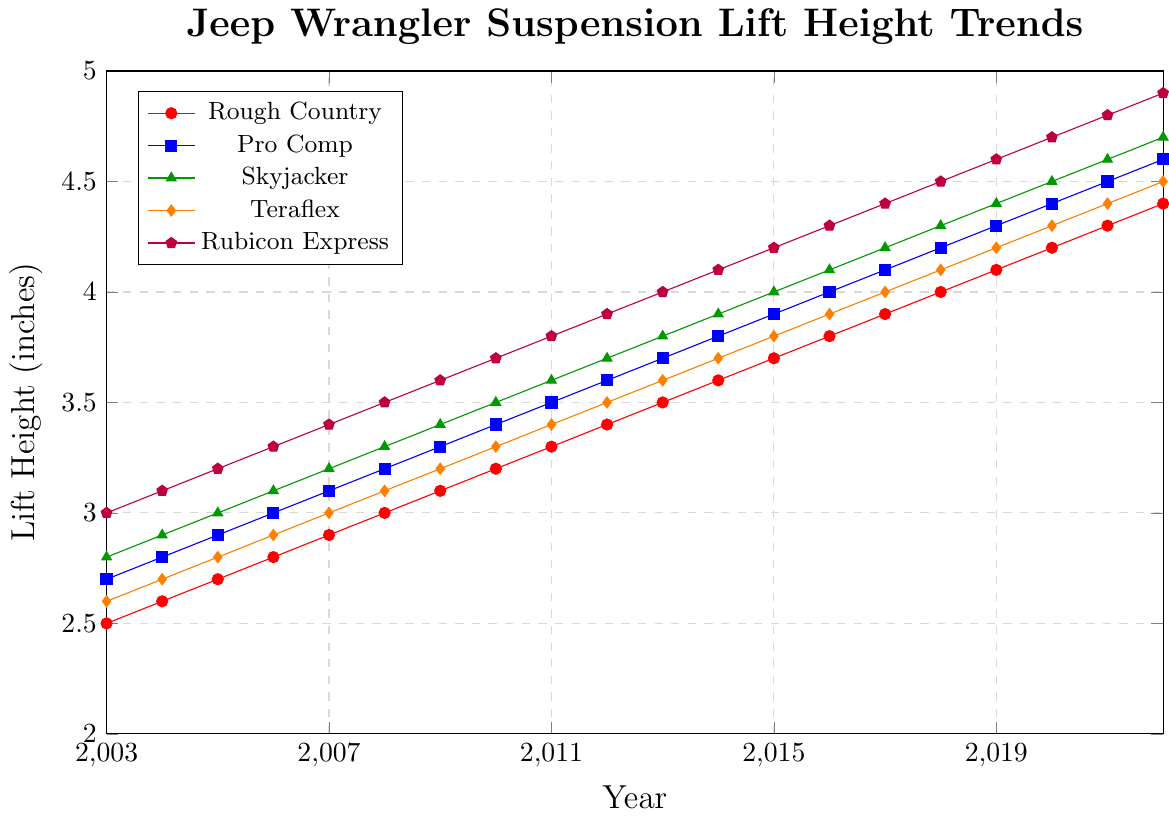Which brand had the highest suspension lift height in 2022? To find the highest suspension lift height in 2022, compare the heights of all brands for that year. Rubicon Express has the highest value of 4.9 inches.
Answer: Rubicon Express How much did the Rough Country lift height increase from 2003 to 2022? Look at the values for Rough Country in 2003 (2.5 inches) and 2022 (4.4 inches). Calculate the increase: 4.4 - 2.5 = 1.9 inches.
Answer: 1.9 inches Which brand showed the most consistent annual increase in lift height? Examine all the brands' lift heights year by year. Each brand increases consistently. However, comparing carefully, all brands have maintained a consistent annual increase of 0.1 inches over the years. There's no single brand that stands out in consistency.
Answer: All brands equally consistent What is the average lift height of Teraflex from 2003 to 2022? Add all the yearly lift heights of Teraflex from 2003 to 2022 and divide by the number of years. (2.6+2.7+2.8+2.9+3.0+3.1+3.2+3.3+3.4+3.5+3.6+3.7+3.8+3.9+4.0+4.1+4.2+4.3+4.4+4.5) / 20 = 3.54 inches.
Answer: 3.54 inches Which year did Rubicon Express first exceed a lift height of 4 inches? Check the values for Rubicon Express year by year to find the first instance where the lift height is greater than 4 inches. In 2013, Rubicon Express had a lift height of 4.0 inches.
Answer: 2013 Compare the lift heights of Pro Comp and Skyjacker in 2020. Which one was higher and by how much? For 2020, Pro Comp had a lift height of 4.4 inches and Skyjacker had 4.5 inches. Subtract Pro Comp's height from Skyjacker's: 4.5 - 4.4 = 0.1 inches.
Answer: Skyjacker by 0.1 inches Which brand had the lowest initial lift height in 2003, and what was that height? Look at the 2003 values for each brand. Rough Country had the lowest initial lift height of 2.5 inches in 2003.
Answer: Rough Country, 2.5 inches What is the median lift height of Rubicon Express over the 20-year period? List out all the values for Rubicon Express from 2003 to 2022 and find the median value, which is the middle number in the ordered set. The ordered list is: 3.0, 3.1, 3.2, 3.3, 3.4, 3.5, 3.6, 3.7, 3.8, 3.9, 4.0, 4.1, 4.2, 4.3, 4.4, 4.5, 4.6, 4.7, 4.8, 4.9. The median is the middle value = 3.95.
Answer: 3.95 In which year did Pro Comp reach a lift height of 4 inches? Look through the yearly lift heights for Pro Comp to find when it first reached 4 inches. In 2016, Pro Comp reached the lift height of 4.0 inches.
Answer: 2016 